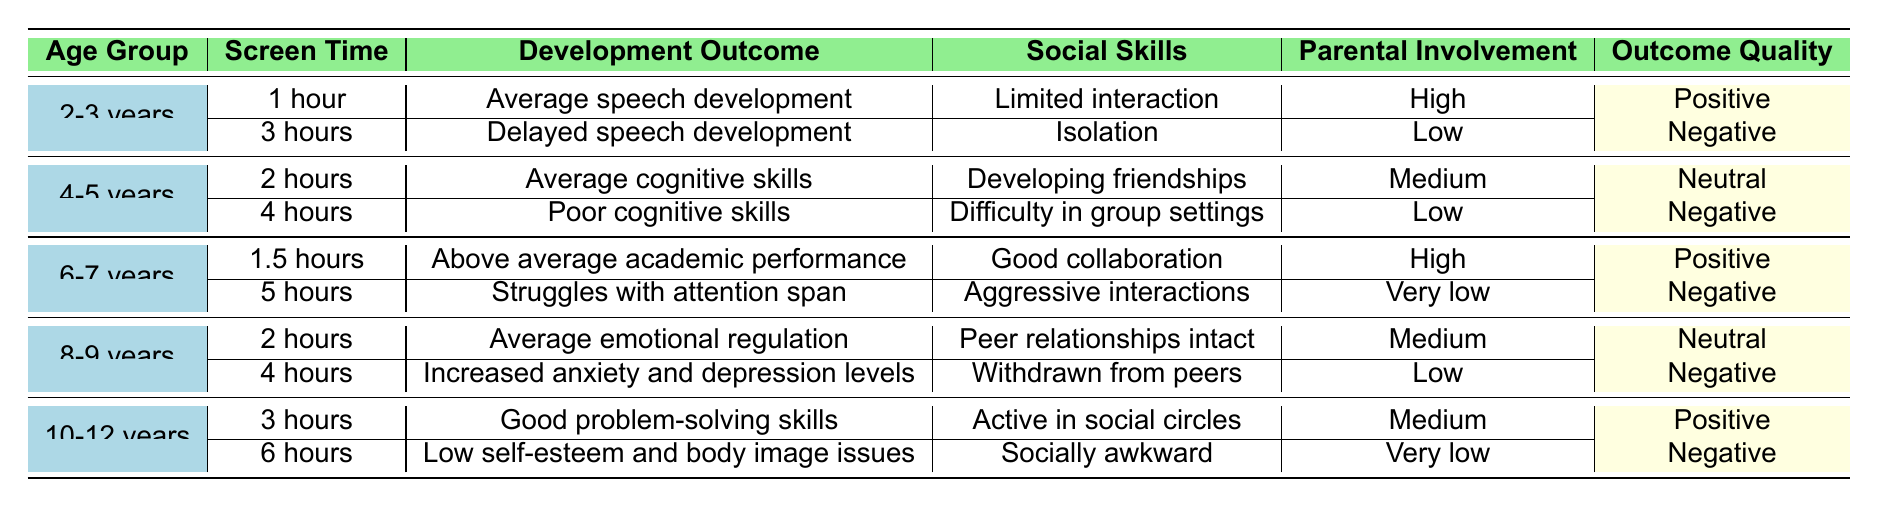What developmental outcome is reported for children aged 2-3 years who have 1 hour of screen time? According to the table, for children aged 2-3 years with 1 hour of screen time, the developmental outcome is "Average speech development."
Answer: Average speech development How does parental involvement differ between children aged 2-3 years with 3 hours of screen time compared to those with 1 hour? For children aged 2-3 years with 1 hour of screen time, parental involvement is "High," while for those with 3 hours, it is "Low." This indicates a decrease in parental involvement with increased screen time.
Answer: Decreases from High to Low What social skills are associated with children aged 6-7 years who watch 5 hours of screen time? The table states that children aged 6-7 years who have 5 hours of screen time exhibit "Aggressive interactions" in terms of social skills.
Answer: Aggressive interactions Is there a negative outcome for children aged 10-12 years who spend 6 hours on screen time? Yes, according to the table, the outcome for children aged 10-12 years with 6 hours of screen time is "Low self-esteem and body image issues," which is classified as a negative outcome.
Answer: Yes For children aged 4-5 years, what is the average screen time when comparing those with neutral outcomes to those with negative outcomes? The children aged 4-5 years with neutral outcomes have 2 hours of screen time, while those with negative outcomes have 4 hours. To find the average: (2 hours + 4 hours) / 2 = 3 hours.
Answer: 3 hours What percentage of ages listed in the table have a positive outcome associated with their screen time? There are 10 total entries in the table. The outcomes classified as positive occur for age groups 2-3 years and 6-7 years (2 entries), so the percentage is (2/10) * 100 = 20%.
Answer: 20% What is the relationship between screen time and social skills for children aged 8-9 years who have 4 hours of screen time? For 8-9 year-olds with 4 hours of screen time, they show "Withdrawn from peers," indicating poor social skills as per the data in the table.
Answer: Withdrawn from peers How do the developmental outcomes compare between children aged 10-12 years watching 3 hours versus 6 hours? For children aged 10-12 years, the outcome for 3 hours is "Good problem-solving skills," while for 6 hours, it is "Low self-esteem and body image issues." The comparison shows that more screen time correlates with a negative outcome.
Answer: More screen time correlates with a negative outcome What social skills are reported for children aged 4-5 years with 2 hours of screen time? The table indicates that children aged 4-5 years with 2 hours of screen time have "Developing friendships" as their social skills outcome.
Answer: Developing friendships 